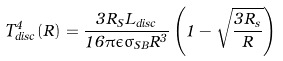Convert formula to latex. <formula><loc_0><loc_0><loc_500><loc_500>T _ { d i s c } ^ { 4 } ( R ) = \frac { 3 R _ { S } L _ { d i s c } } { 1 6 \pi \epsilon \sigma _ { S B } R ^ { 3 } } \left ( 1 - \sqrt { \frac { 3 R _ { s } } { R } } \right )</formula> 